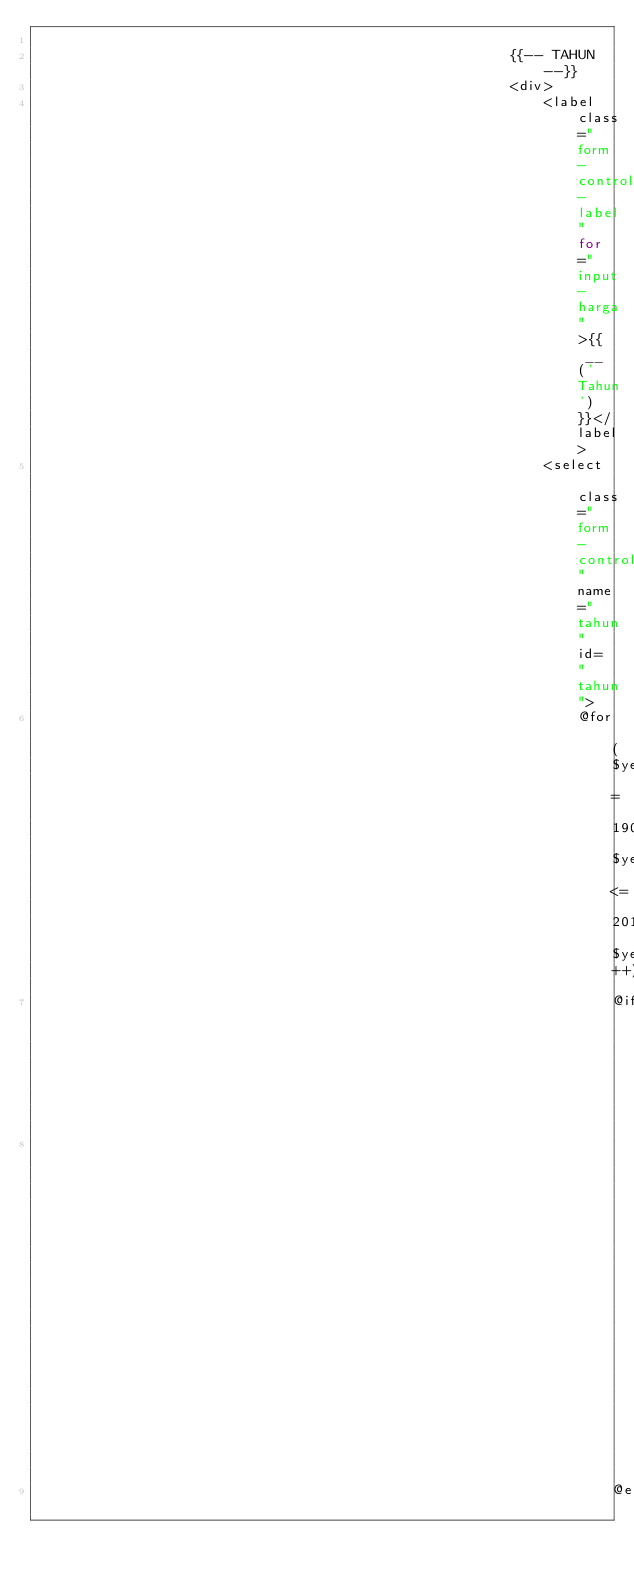Convert code to text. <code><loc_0><loc_0><loc_500><loc_500><_PHP_>
                                                        {{-- TAHUN --}}
                                                        <div>
                                                            <label class="form-control-label" for="input-harga">{{ __('Tahun') }}</label>
                                                            <select class="form-control" name="tahun" id="tahun">
                                                                @for ($year = 1900; $year <= 2019; $year++)
                                                                    @if ($year === 2019)
                                                                        <option value="{{ $year }}" selected>{{ $year }}</option>  
                                                                    @else</code> 